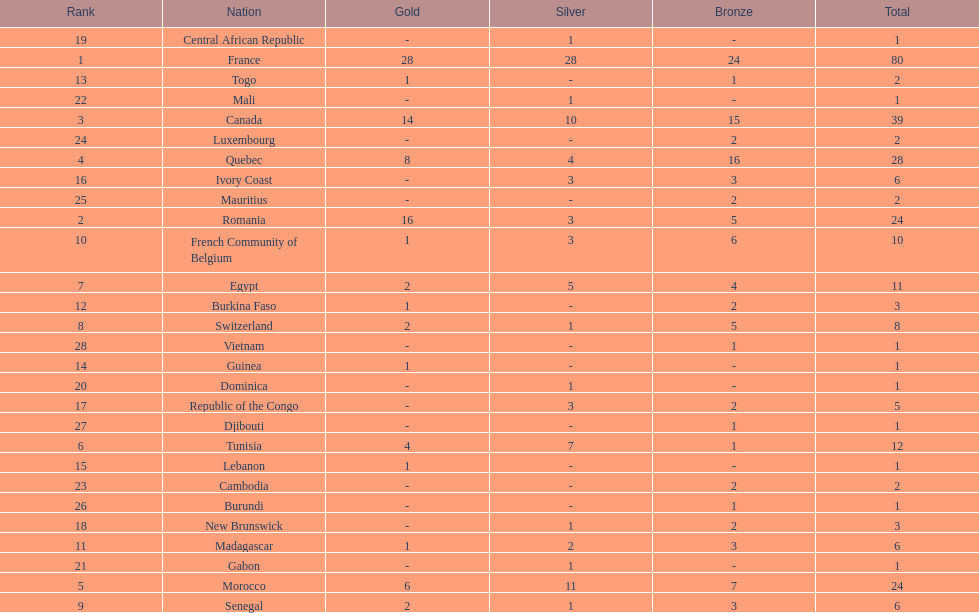How many more medals did egypt win than ivory coast? 5. 